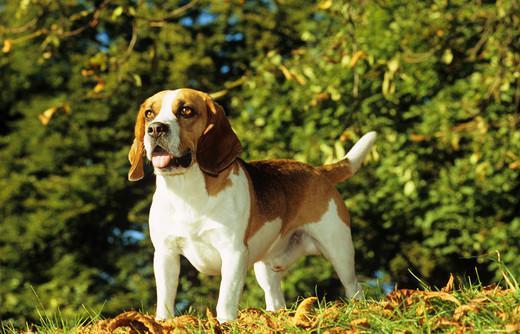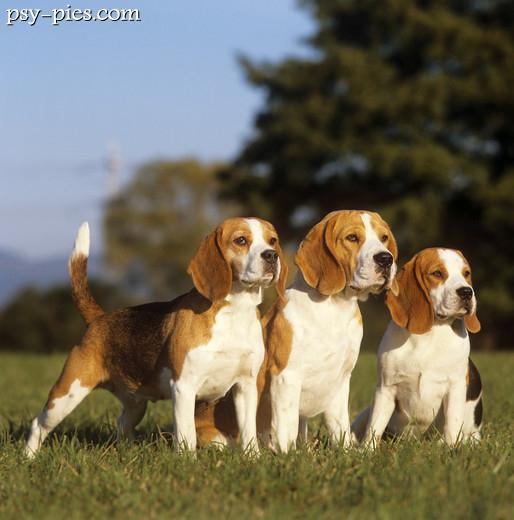The first image is the image on the left, the second image is the image on the right. Evaluate the accuracy of this statement regarding the images: "At least one of the images shows three or more dogs.". Is it true? Answer yes or no. Yes. The first image is the image on the left, the second image is the image on the right. Given the left and right images, does the statement "In total, images contain no more than three beagles." hold true? Answer yes or no. No. 